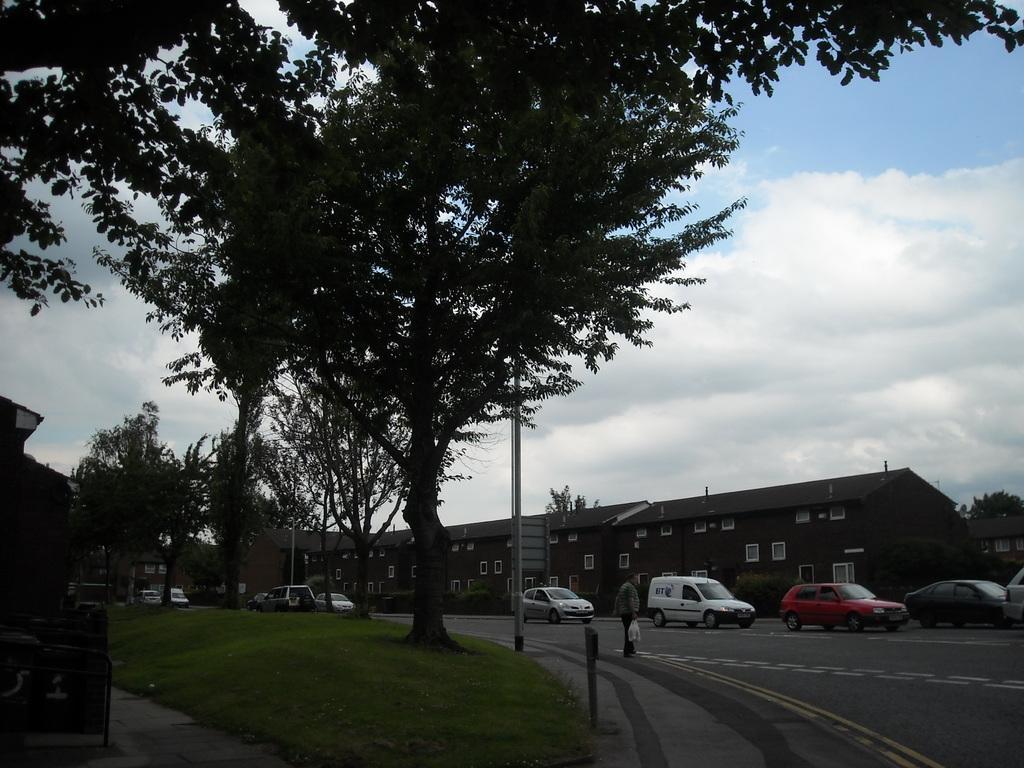Please provide a concise description of this image. In this given picture, I can see a person holding a carry bag and a road after that, We can see a few cars and a building with multiple windows towards left in middle, We can see couple of trees, a green grass. 